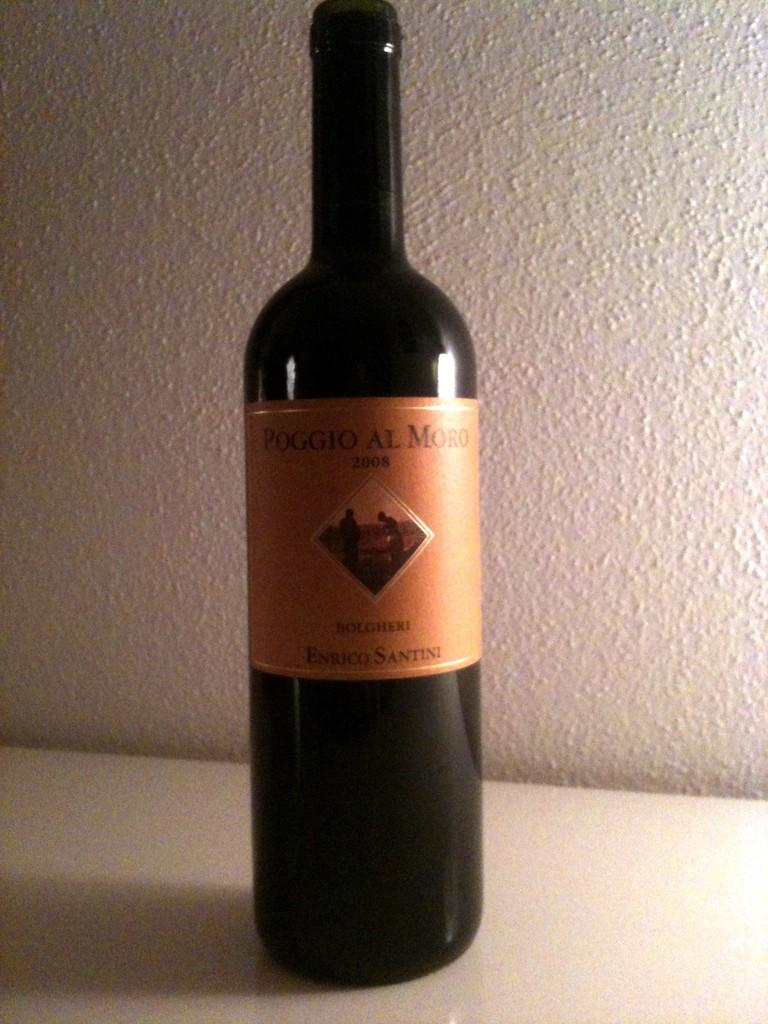<image>
Describe the image concisely. Black bottle with a gold label from the year 2008. 